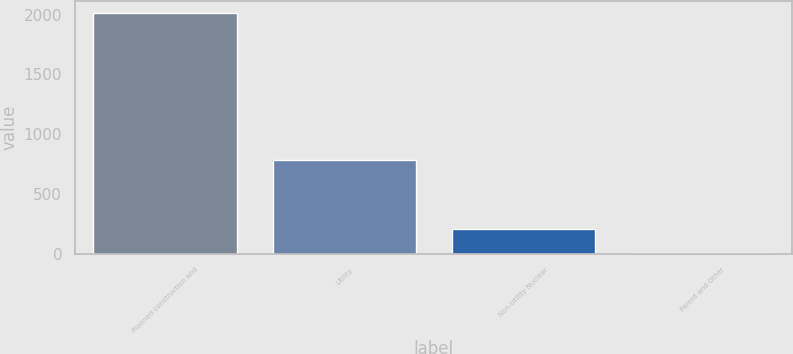Convert chart to OTSL. <chart><loc_0><loc_0><loc_500><loc_500><bar_chart><fcel>Planned construction and<fcel>Utility<fcel>Non-Utility Nuclear<fcel>Parent and Other<nl><fcel>2011<fcel>783<fcel>207.4<fcel>7<nl></chart> 